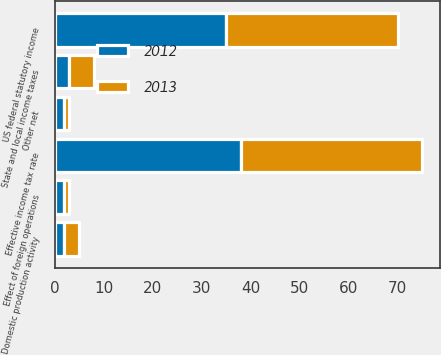Convert chart. <chart><loc_0><loc_0><loc_500><loc_500><stacked_bar_chart><ecel><fcel>US federal statutory income<fcel>State and local income taxes<fcel>Effect of foreign operations<fcel>Domestic production activity<fcel>Other net<fcel>Effective income tax rate<nl><fcel>2012<fcel>35<fcel>3<fcel>2<fcel>2<fcel>2<fcel>38<nl><fcel>2013<fcel>35<fcel>5<fcel>1<fcel>3<fcel>1<fcel>37<nl></chart> 